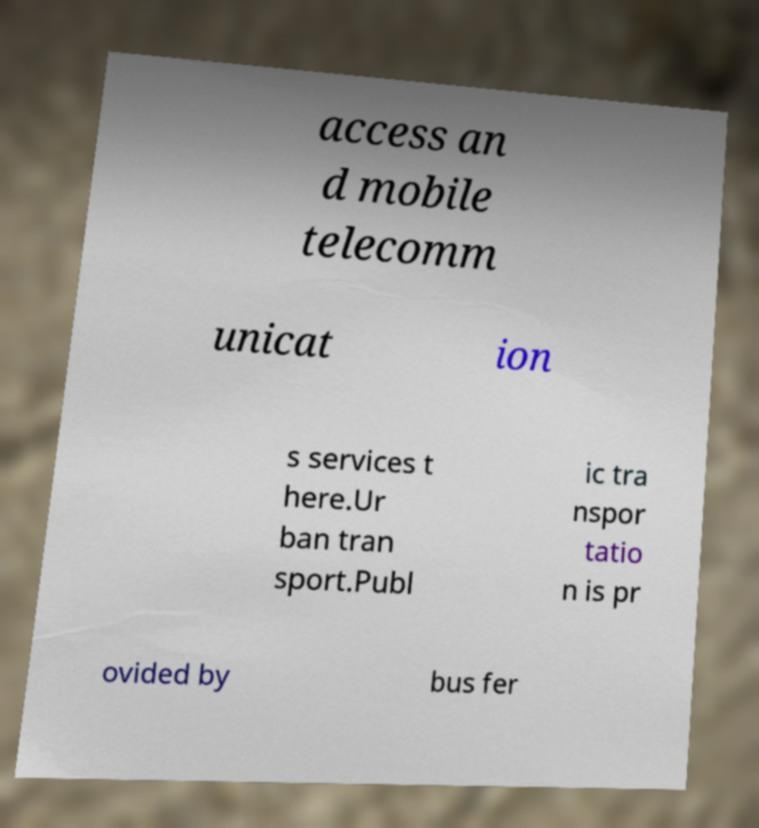I need the written content from this picture converted into text. Can you do that? access an d mobile telecomm unicat ion s services t here.Ur ban tran sport.Publ ic tra nspor tatio n is pr ovided by bus fer 